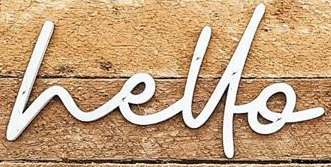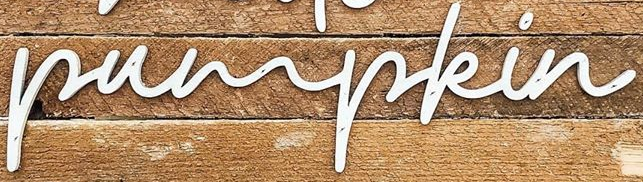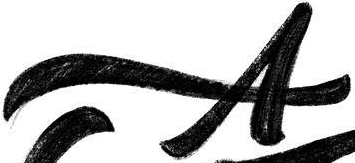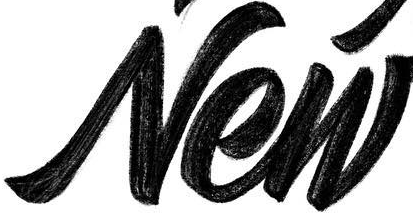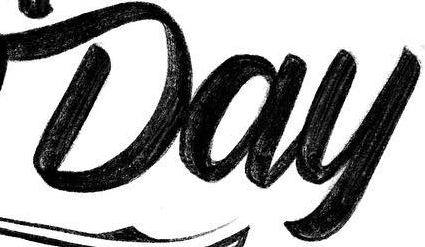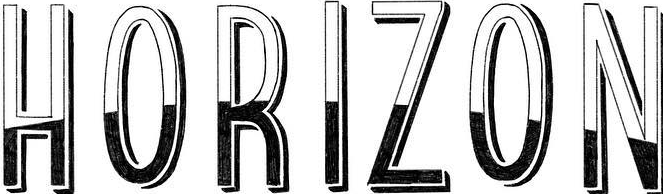Transcribe the words shown in these images in order, separated by a semicolon. hello; pumpkin; A; New; Day; HORIZON 